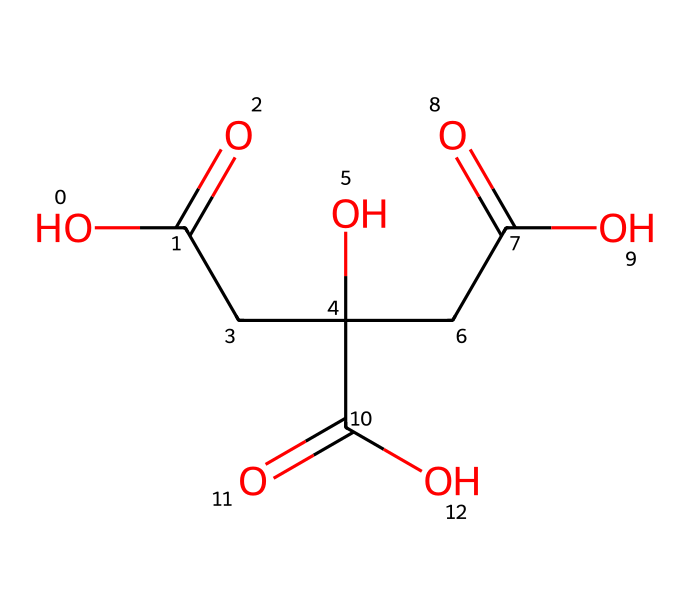How many carbon atoms are in citric acid? In the molecular structure of citric acid, the SMILES representation shows that there are a total of 6 carbon atoms, as observed in the formula where each 'C' represents a carbon atom.
Answer: 6 What is the primary functional group in citric acid? The molecular structure reveals the presence of multiple carboxylic acid groups (-COOH), which is the defining characteristic of citric acid.
Answer: carboxylic acid How many hydroxyl groups are present in citric acid? Analyzing the structure, there is one hydroxyl group (-OH) visible in the SMILES representation, indicated by the 'O' connected to a carbon atom.
Answer: 1 What type of compound is citric acid categorized as? Based on the presence of multiple carboxylic acid functional groups, citric acid is categorized as a tricarboxylic acid, specifically due to having three -COOH groups.
Answer: tricarboxylic acid How many total oxygen atoms are in citric acid? By examining the SMILES representation, there are 7 oxygen atoms present; counting each 'O' and including those in the carboxylic acid groups leads to the total.
Answer: 7 What is the pH characteristic of citric acid when dissolved in water? Citric acid is a weak acid, which typically results in a solution with a pH less than 7. Its acidic properties stem from its carboxylic acid groups.
Answer: less than 7 Does citric acid serve as a preservative? Yes, citric acid is widely recognized for its ability to inhibit the growth of bacteria and mold, providing a preservation effect in various food products.
Answer: yes 